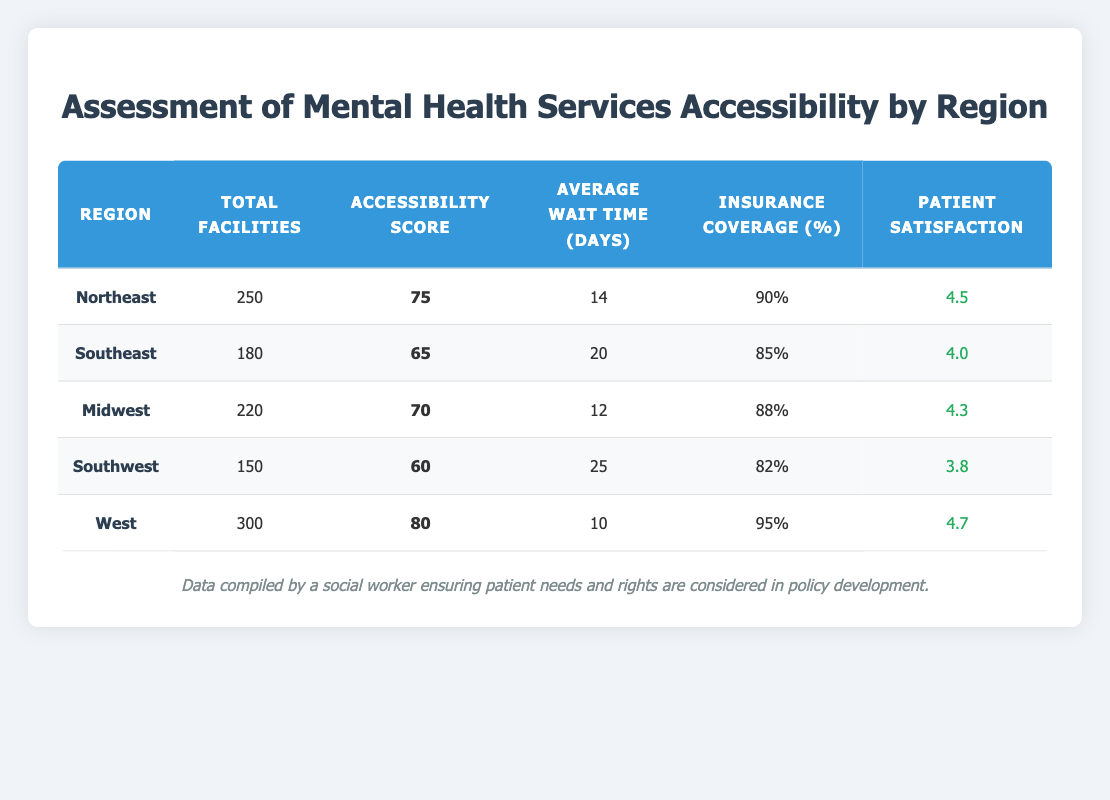What is the Total Facilities in the West region? The table directly shows the Total Facilities for the West region as 300.
Answer: 300 What is the Accessibility Score for the Southeast region? According to the table, the Accessibility Score for the Southeast region is 65.
Answer: 65 Which region has the highest Patient Satisfaction Rating? By comparing the Patient Satisfaction Ratings, the West region has the highest rating of 4.7.
Answer: West What is the average wait time for mental health services in the Midwest and Northeast regions combined? The average wait time for the Midwest is 12 days and for the Northeast is 14 days. The sum is 12 + 14 = 26, and averaging that: 26/2 = 13 days.
Answer: 13 days Is the Insurance Coverage Percentage in the Southwest region less than 85%? The table shows that the Insurance Coverage Percentage in the Southwest region is 82%, which is less than 85%.
Answer: Yes Which region has the lowest Accessibility Score, and what is that score? The Southwest region has the lowest Accessibility Score of 60 based on the table.
Answer: Southwest, 60 What is the difference in Patient Satisfaction Rating between the West and Southwest regions? The Patient Satisfaction Rating for the West is 4.7 and for the Southwest is 3.8, so the difference is 4.7 - 3.8 = 0.9.
Answer: 0.9 How many more Total Facilities does the Northeast region have compared to the Southwest region? The Northeast region has 250 Total Facilities and the Southwest has 150, so the difference is 250 - 150 = 100.
Answer: 100 What is the average Insurance Coverage Percentage across all regions? The Insurance Coverage Percentages are 90%, 85%, 88%, 82%, and 95%. The sum is 90 + 85 + 88 + 82 + 95 = 440. Dividing by the number of regions (5) gives: 440/5 = 88%.
Answer: 88% 